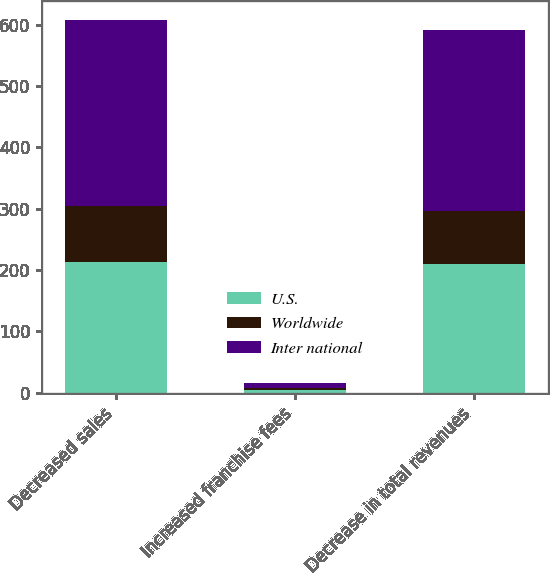<chart> <loc_0><loc_0><loc_500><loc_500><stacked_bar_chart><ecel><fcel>Decreased sales<fcel>Increased franchise fees<fcel>Decrease in total revenues<nl><fcel>U.S.<fcel>214<fcel>4<fcel>210<nl><fcel>Worldwide<fcel>90<fcel>4<fcel>86<nl><fcel>Inter national<fcel>304<fcel>8<fcel>296<nl></chart> 